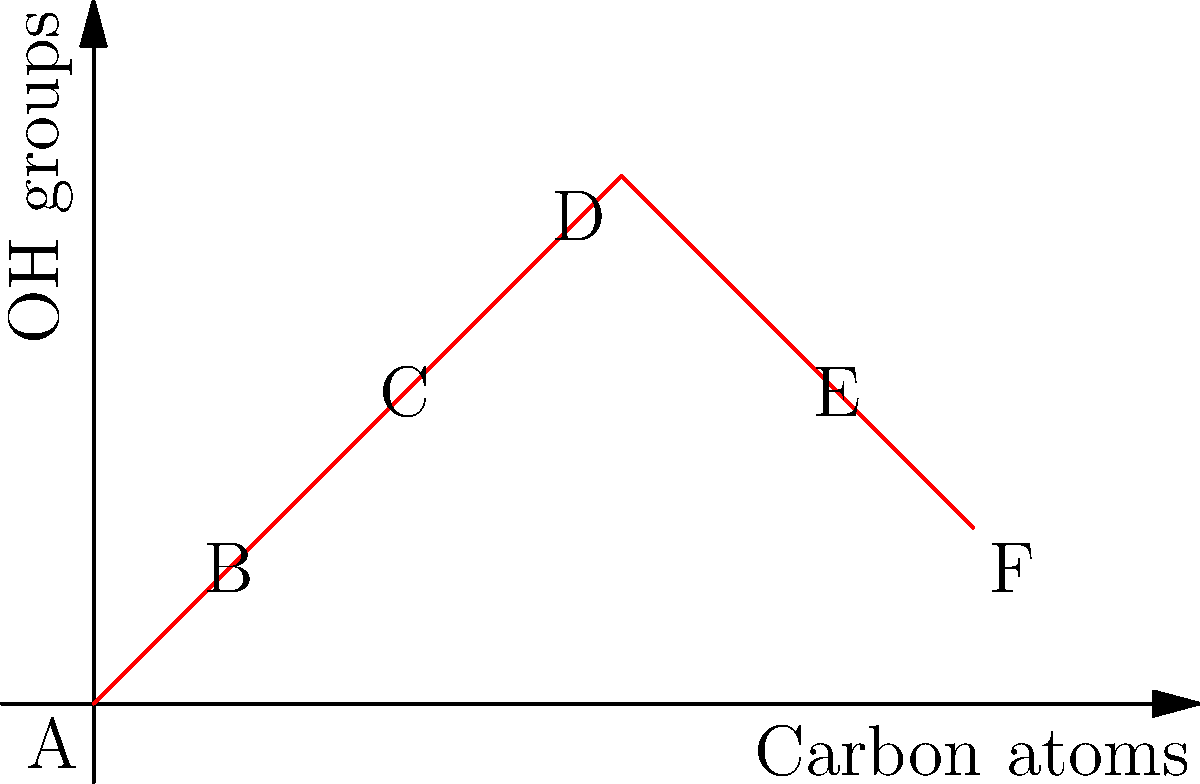The graph represents the relationship between the number of carbon atoms and hydroxyl (OH) groups in a series of common humectants used in cosmetic formulations. Which point on the graph most likely represents glycerin, a widely used humectant in skincare products? To identify which point represents glycerin, we need to consider its molecular structure:

1. Glycerin (also known as glycerol) has the molecular formula $C_3H_8O_3$.
2. It contains 3 carbon atoms in its backbone.
3. It has 3 hydroxyl (OH) groups attached to its carbon chain.

Analyzing the graph:
- The x-axis represents the number of carbon atoms.
- The y-axis represents the number of hydroxyl (OH) groups.

Looking at the points on the graph:
- Point A (0,0): No carbon atoms, no OH groups - not possible for a humectant.
- Point B (1,1): 1 carbon atom, 1 OH group - too small for glycerin.
- Point C (2,2): 2 carbon atoms, 2 OH groups - close, but not glycerin.
- Point D (3,3): 3 carbon atoms, 3 OH groups - matches glycerin's structure.
- Point E (4,2): 4 carbon atoms, 2 OH groups - not glycerin.
- Point F (5,1): 5 carbon atoms, 1 OH group - not glycerin.

Therefore, point D, with 3 carbon atoms and 3 OH groups, most likely represents glycerin.
Answer: D 